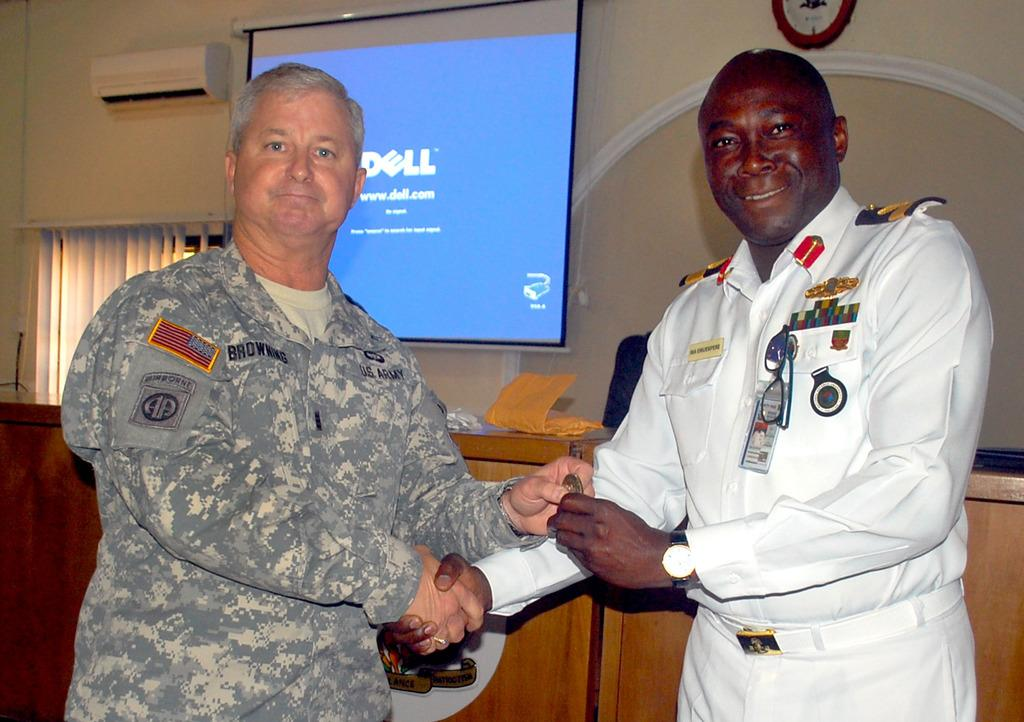<image>
Create a compact narrative representing the image presented. Two men shaking hands in front of a screen which says DELL on it. 